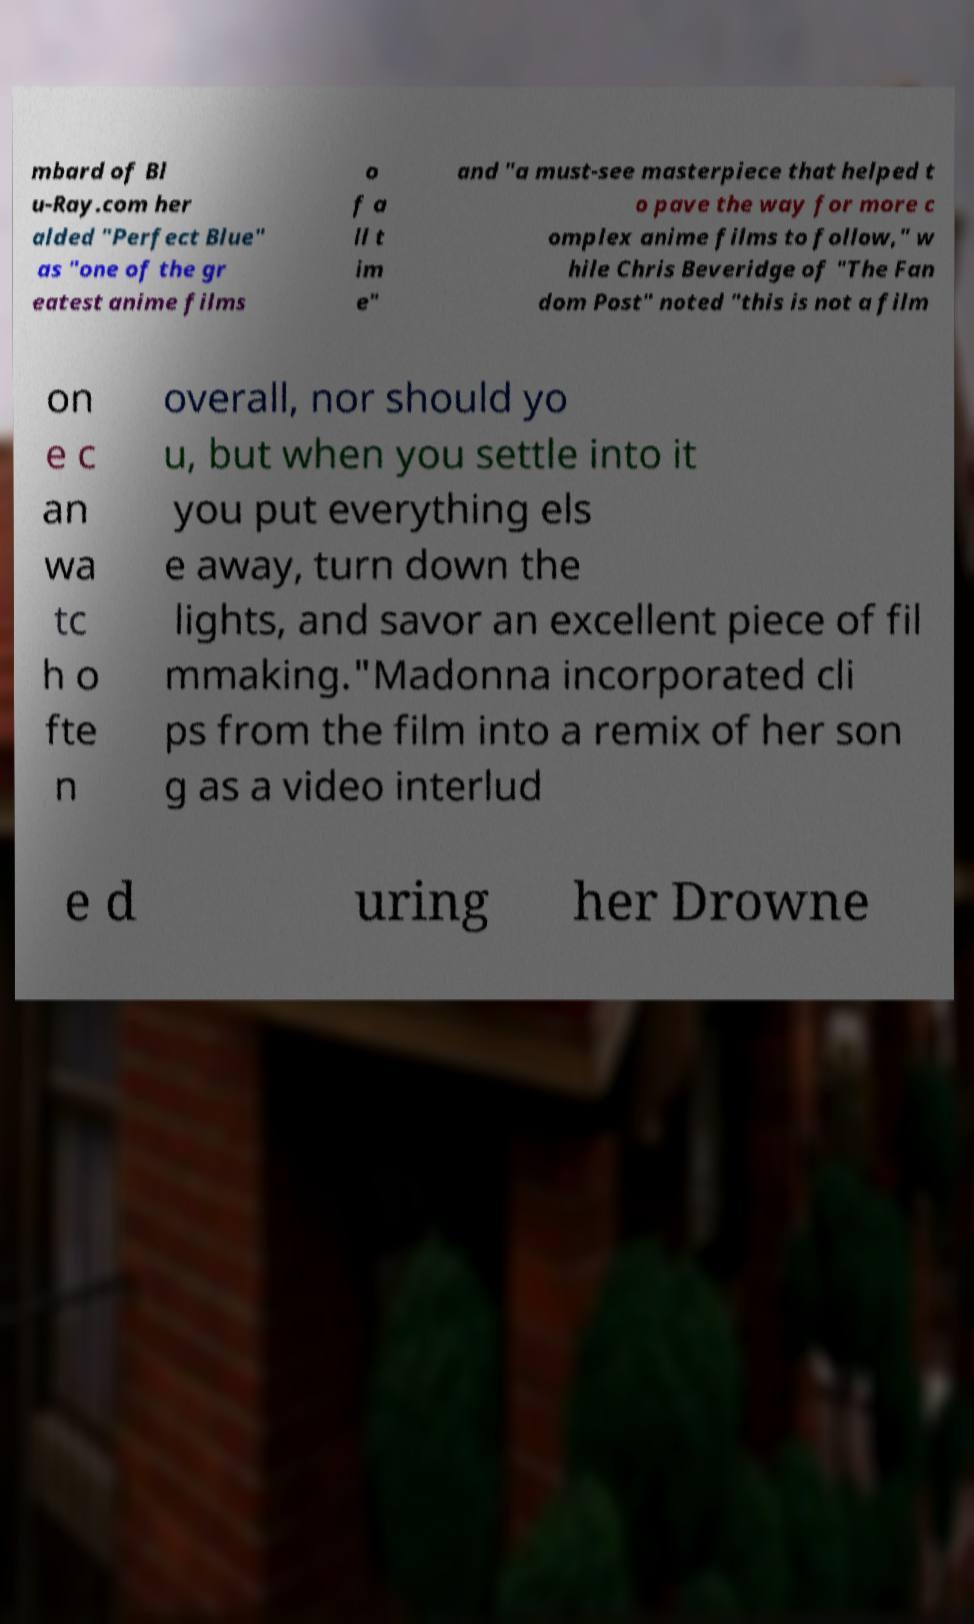What messages or text are displayed in this image? I need them in a readable, typed format. mbard of Bl u-Ray.com her alded "Perfect Blue" as "one of the gr eatest anime films o f a ll t im e" and "a must-see masterpiece that helped t o pave the way for more c omplex anime films to follow," w hile Chris Beveridge of "The Fan dom Post" noted "this is not a film on e c an wa tc h o fte n overall, nor should yo u, but when you settle into it you put everything els e away, turn down the lights, and savor an excellent piece of fil mmaking."Madonna incorporated cli ps from the film into a remix of her son g as a video interlud e d uring her Drowne 